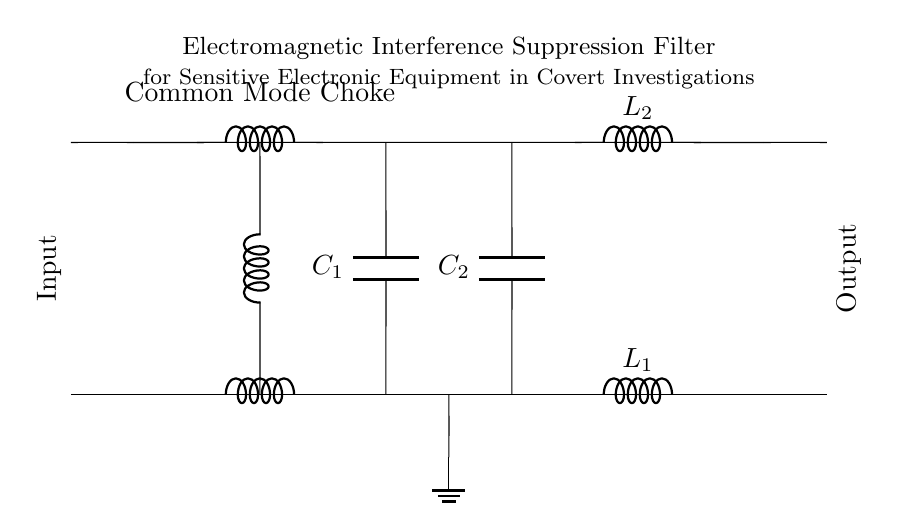What is the type of this filter? The circuit diagram depicts an electromagnetic interference suppression filter, which is specifically designed to reduce unwanted electromagnetic noise in sensitive electronic equipment.
Answer: Electromagnetic interference suppression filter How many inductors are present in the circuit? The diagram shows a total of three inductors: one common mode choke represented by two inductors and two differential mode inductors labeled L1 and L2.
Answer: Three What is the function of the common mode choke in this filter? The common mode choke is used to block common mode noise while allowing differential signals to pass, which helps in reducing interference from external electromagnetic sources.
Answer: Block common mode noise What is the role of capacitors in this filter? Capacitors in the circuit (C1 and C2) are used for filtering out high-frequency noise and stabilize voltage levels, ensuring smooth operation of the connected equipment.
Answer: Filter high-frequency noise What is the output connection point of this filter? The output connection point is on the right side of the circuit diagram, where the signal exits the filter after passing through the components.
Answer: Right side How does the number and type of components affect the filter's performance? The combination and arrangement of components such as inductors and capacitors determine the filter's ability to attenuate specific frequency ranges of electromagnetic interference, thus affecting its overall performance and efficiency.
Answer: Affects performance 